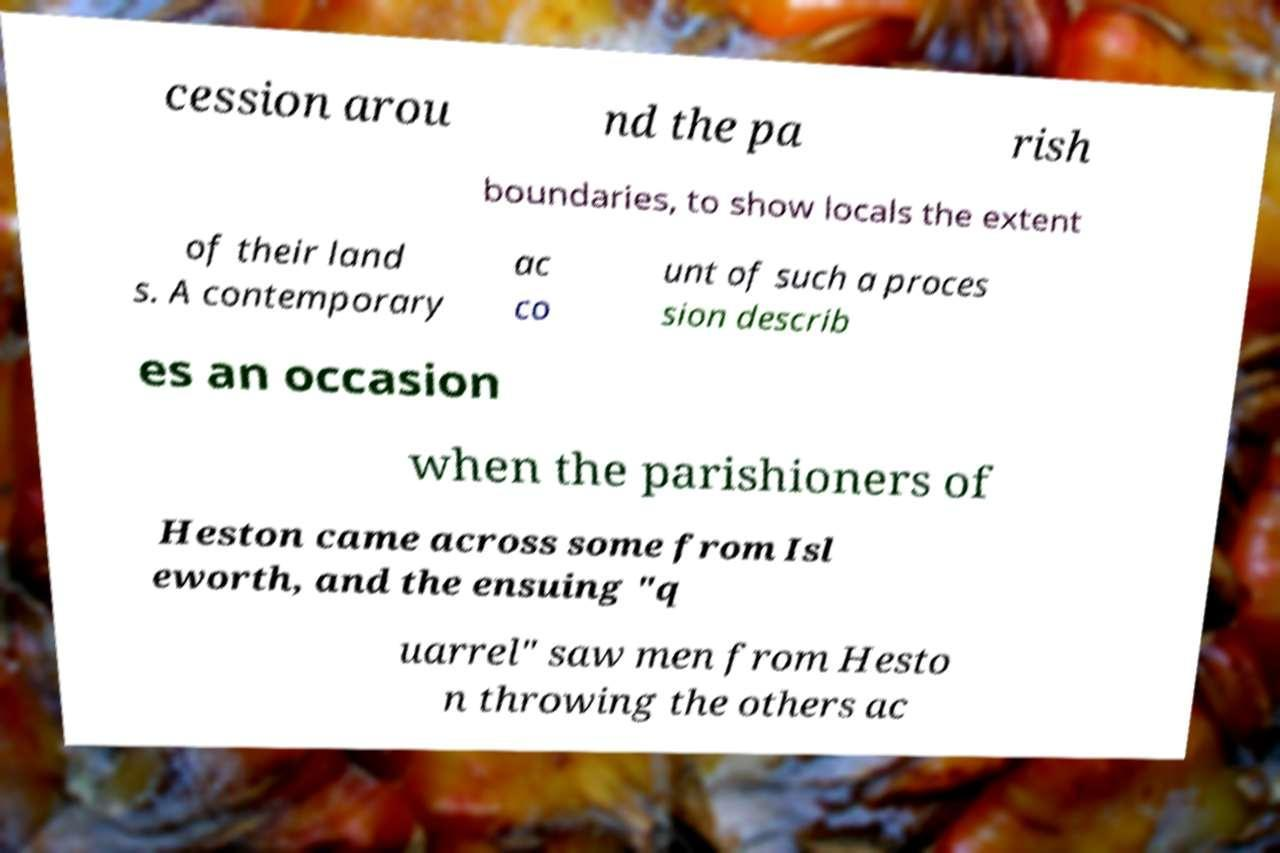What messages or text are displayed in this image? I need them in a readable, typed format. cession arou nd the pa rish boundaries, to show locals the extent of their land s. A contemporary ac co unt of such a proces sion describ es an occasion when the parishioners of Heston came across some from Isl eworth, and the ensuing "q uarrel" saw men from Hesto n throwing the others ac 